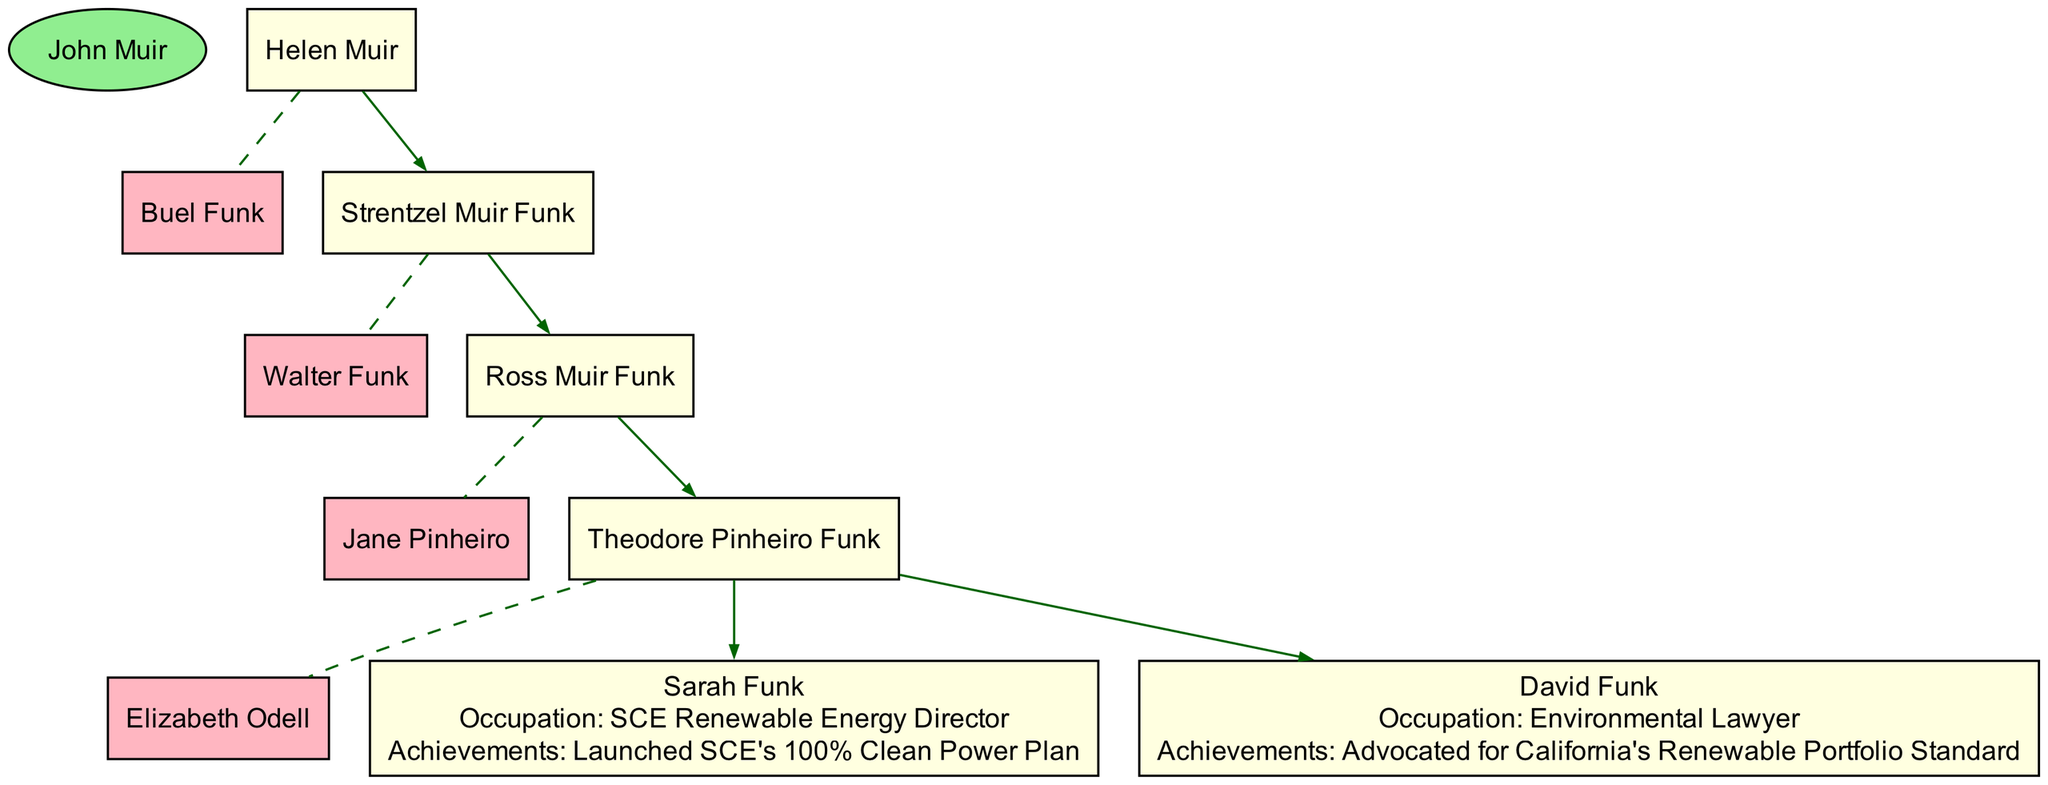What is the name of the family root? The family root is clearly labeled at the top of the diagram, which states "John Muir" as the starting point of this family lineage.
Answer: John Muir Who is the spouse of Strentzel Muir Funk? According to the diagram, the spouse of Strentzel Muir Funk is listed directly next to their name, which states "Walter Funk" as their partner.
Answer: Walter Funk How many children does Theodore Pinheiro Funk have? From the diagram, we can count the number of children listed under Theodore Pinheiro Funk. It shows two children: "Sarah Funk" and "David Funk."
Answer: 2 What is the occupation of Sarah Funk? The occupation of Sarah Funk is specified in the diagram, where it explicitly mentions "SCE Renewable Energy Director" next to her name, which identifies her role clearly.
Answer: SCE Renewable Energy Director Who is the child of Ross Muir Funk? The diagram indicates that Ross Muir Funk has one child, "Theodore Pinheiro Funk," which can be seen as a direct connection in the lineage.
Answer: Theodore Pinheiro Funk Which generation does David Funk belong to? To determine the generation of David Funk, we analyze the connections in the diagram. David Funk is a child of Theodore Pinheiro Funk, making him part of the fourth generation in this family tree.
Answer: Fourth generation What achievements are credited to David Funk? The diagram provides details about David Funk and specifies his achievements, stating "Advocated for California's Renewable Portfolio Standard," which highlights his contributions.
Answer: Advocated for California's Renewable Portfolio Standard What is the relationship between John Muir and Sarah Funk? To ascertain the relationship, we can trace the lineage upward from Sarah Funk to John Muir. Sarah Funk is a great-grandchild of John Muir, indicating a direct descent through several generations.
Answer: Great-grandchild 